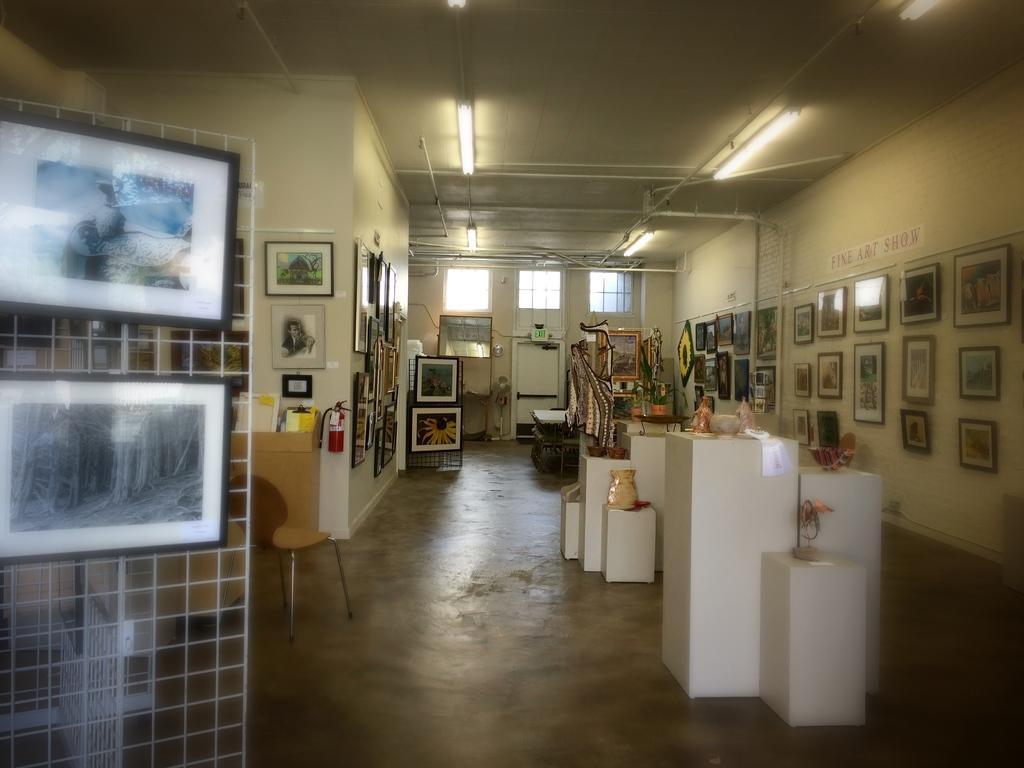In one or two sentences, can you explain what this image depicts? In this image we can see few objects on the tables, there are picture frames to the wall, few picture frames to the grille and there is a fire extinguisher, plug board to the wall, there is a chair near the grille, there are windows to the wall and lights to the ceiling. 